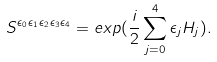Convert formula to latex. <formula><loc_0><loc_0><loc_500><loc_500>S ^ { \epsilon _ { 0 } \epsilon _ { 1 } \epsilon _ { 2 } \epsilon _ { 3 } \epsilon _ { 4 } } = e x p ( \frac { i } { 2 } \sum _ { j = 0 } ^ { 4 } \epsilon _ { j } H _ { j } ) .</formula> 